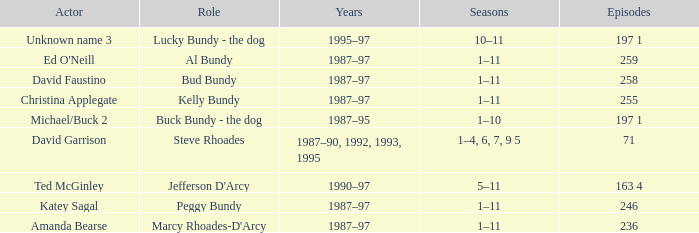Would you mind parsing the complete table? {'header': ['Actor', 'Role', 'Years', 'Seasons', 'Episodes'], 'rows': [['Unknown name 3', 'Lucky Bundy - the dog', '1995–97', '10–11', '197 1'], ["Ed O'Neill", 'Al Bundy', '1987–97', '1–11', '259'], ['David Faustino', 'Bud Bundy', '1987–97', '1–11', '258'], ['Christina Applegate', 'Kelly Bundy', '1987–97', '1–11', '255'], ['Michael/Buck 2', 'Buck Bundy - the dog', '1987–95', '1–10', '197 1'], ['David Garrison', 'Steve Rhoades', '1987–90, 1992, 1993, 1995', '1–4, 6, 7, 9 5', '71'], ['Ted McGinley', "Jefferson D'Arcy", '1990–97', '5–11', '163 4'], ['Katey Sagal', 'Peggy Bundy', '1987–97', '1–11', '246'], ['Amanda Bearse', "Marcy Rhoades-D'Arcy", '1987–97', '1–11', '236']]} How many years did the role of Steve Rhoades last? 1987–90, 1992, 1993, 1995. 